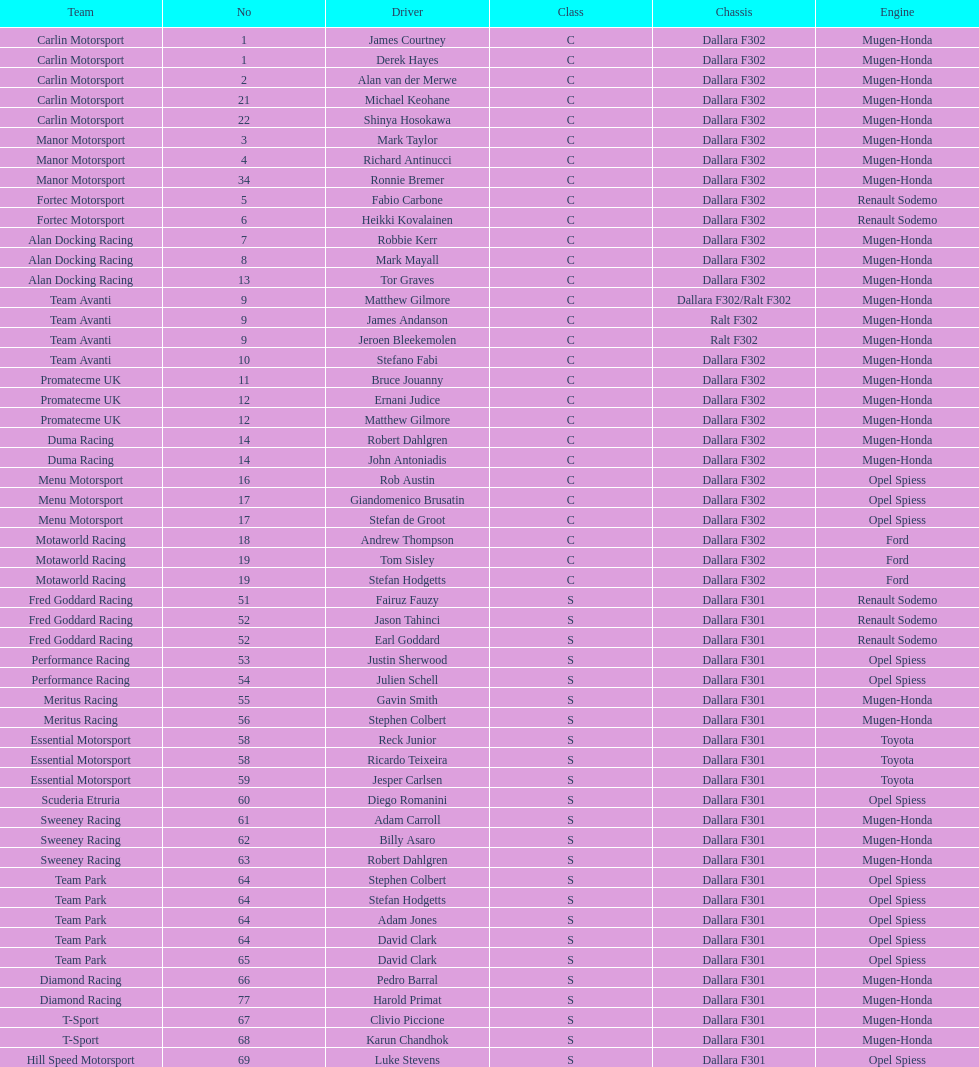Which group is listed prior to diamond racing? Team Park. 